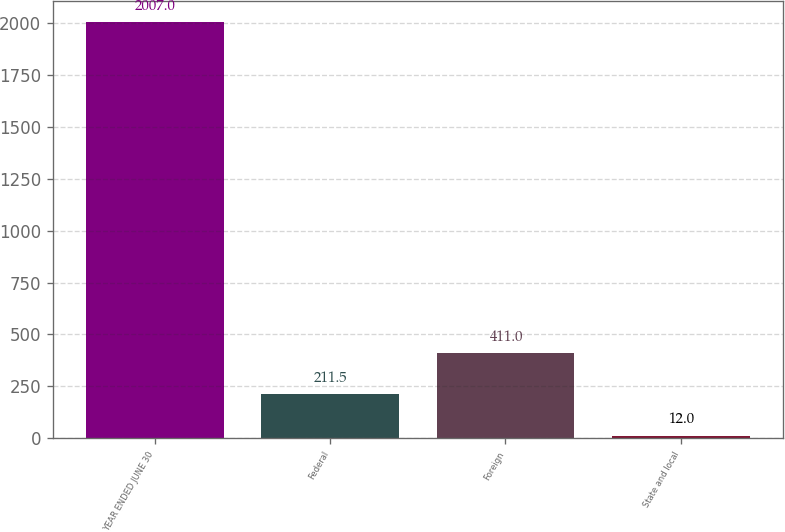<chart> <loc_0><loc_0><loc_500><loc_500><bar_chart><fcel>YEAR ENDED JUNE 30<fcel>Federal<fcel>Foreign<fcel>State and local<nl><fcel>2007<fcel>211.5<fcel>411<fcel>12<nl></chart> 